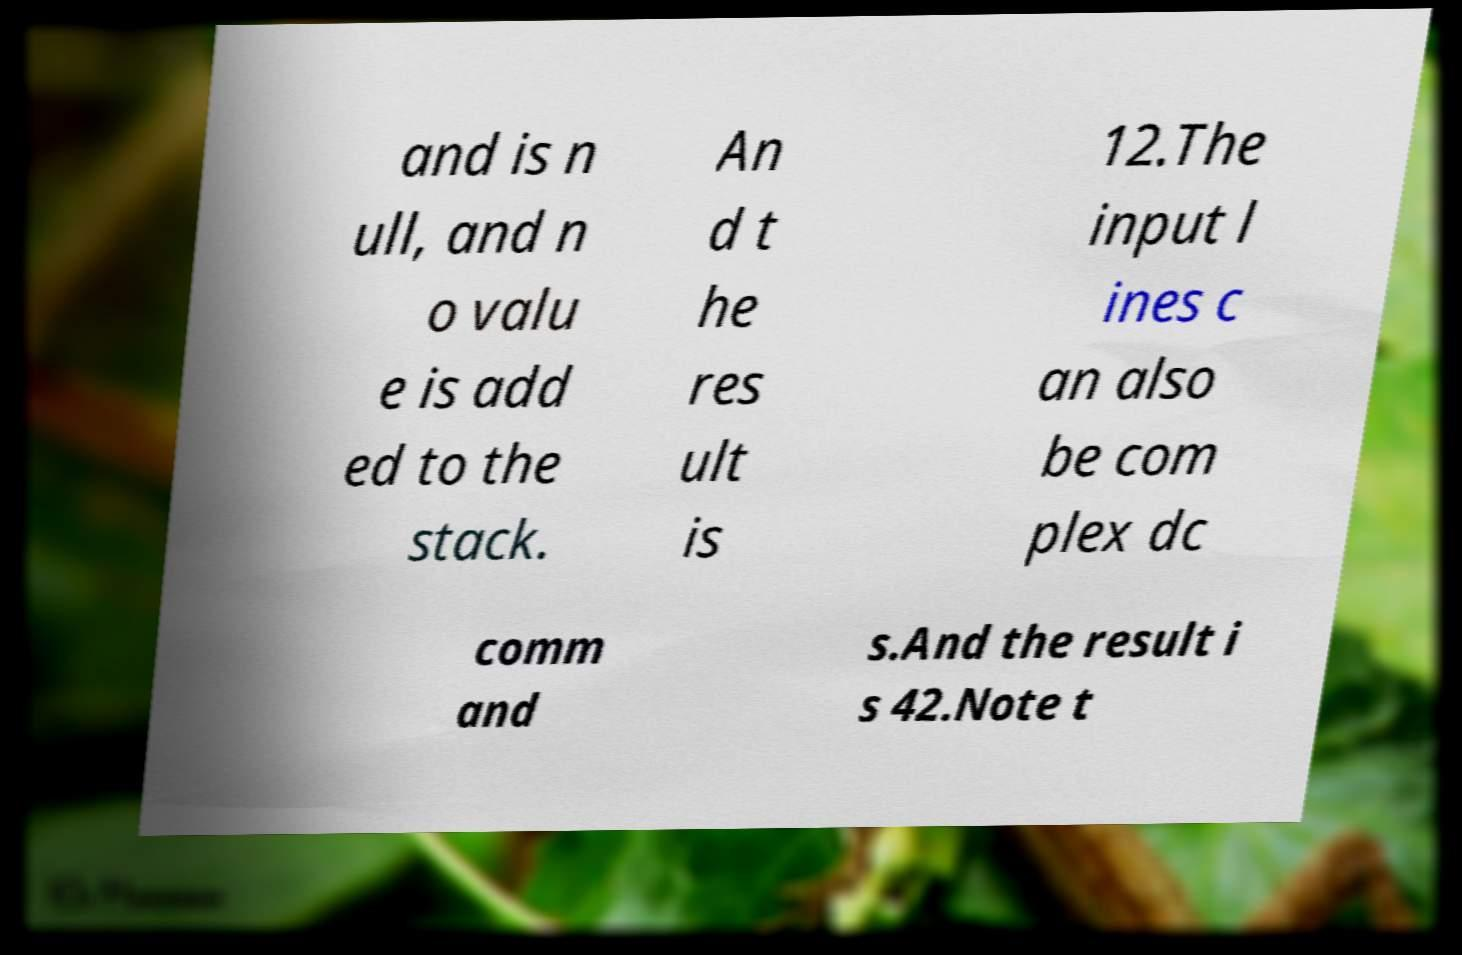Can you read and provide the text displayed in the image?This photo seems to have some interesting text. Can you extract and type it out for me? and is n ull, and n o valu e is add ed to the stack. An d t he res ult is 12.The input l ines c an also be com plex dc comm and s.And the result i s 42.Note t 